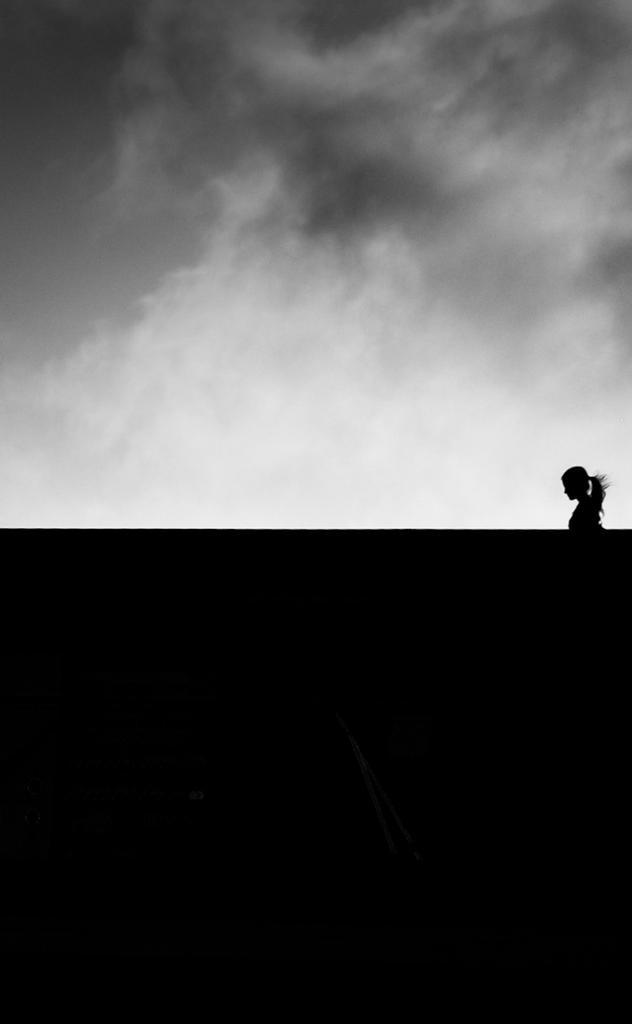In one or two sentences, can you explain what this image depicts? On the right side of the image there is a person. At the bottom there is a wall. In the background we can see sky. 